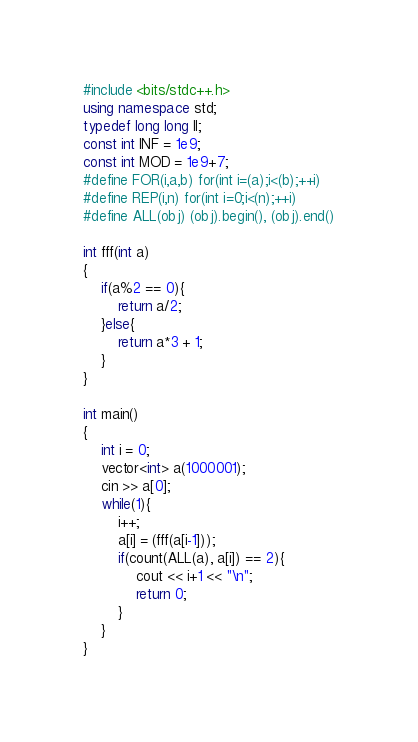<code> <loc_0><loc_0><loc_500><loc_500><_C++_>#include <bits/stdc++.h>
using namespace std;
typedef long long ll;
const int INF = 1e9;
const int MOD = 1e9+7;
#define FOR(i,a,b) for(int i=(a);i<(b);++i)
#define REP(i,n) for(int i=0;i<(n);++i)
#define ALL(obj) (obj).begin(), (obj).end()

int fff(int a)
{
	if(a%2 == 0){
		return a/2;
	}else{
		return a*3 + 1;
	}
}

int main()
{
	int i = 0;
	vector<int> a(1000001);
	cin >> a[0];
	while(1){
		i++;
		a[i] = (fff(a[i-1]));
		if(count(ALL(a), a[i]) == 2){
			cout << i+1 << "\n";
			return 0;
		}
	}
}
</code> 